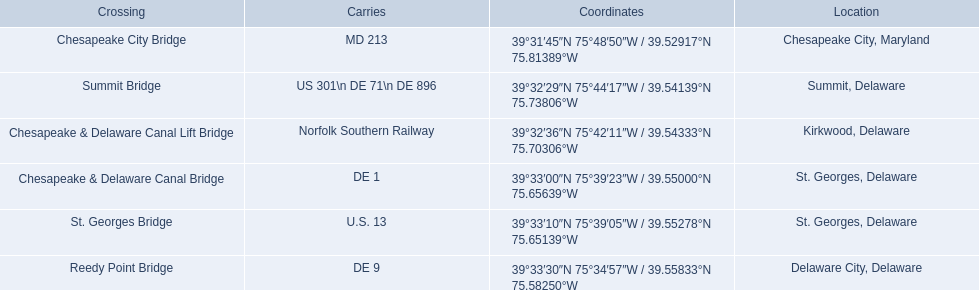What gets carried within the canal? MD 213, US 301\n DE 71\n DE 896, Norfolk Southern Railway, DE 1, U.S. 13, DE 9. Which of those carries de 9? DE 9. To what crossing does that entry correspond? Reedy Point Bridge. 